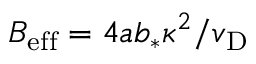<formula> <loc_0><loc_0><loc_500><loc_500>B _ { e f f } = 4 a b _ { * } \kappa ^ { 2 } / v _ { D }</formula> 